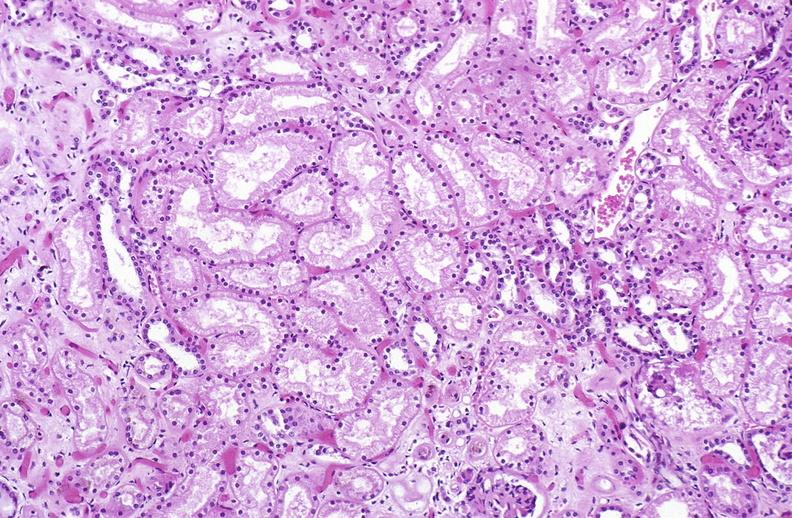s digital infarcts bacterial endocarditis present?
Answer the question using a single word or phrase. No 